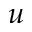<formula> <loc_0><loc_0><loc_500><loc_500>u</formula> 